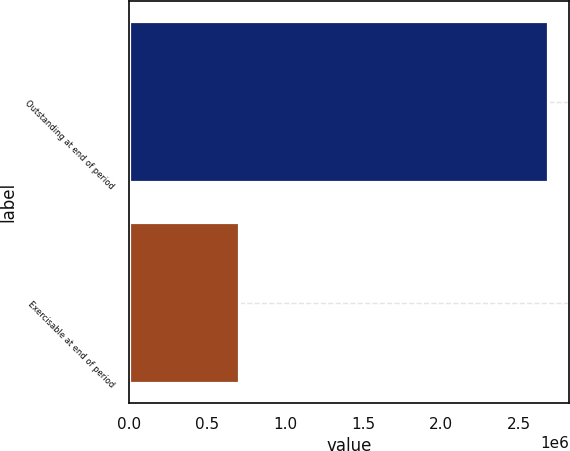<chart> <loc_0><loc_0><loc_500><loc_500><bar_chart><fcel>Outstanding at end of period<fcel>Exercisable at end of period<nl><fcel>2.68252e+06<fcel>703879<nl></chart> 